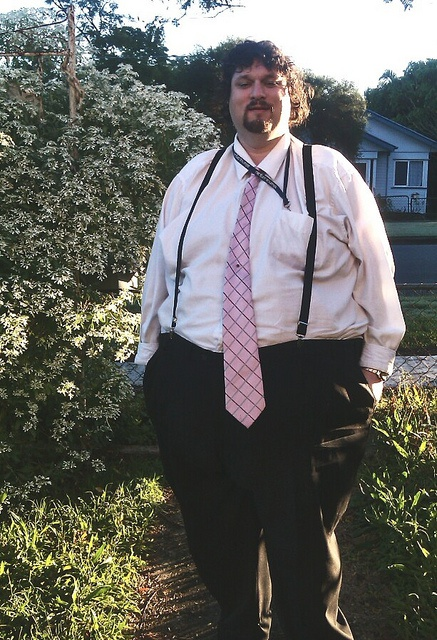Describe the objects in this image and their specific colors. I can see people in white, black, lavender, and darkgray tones and tie in white, lightpink, gray, and pink tones in this image. 